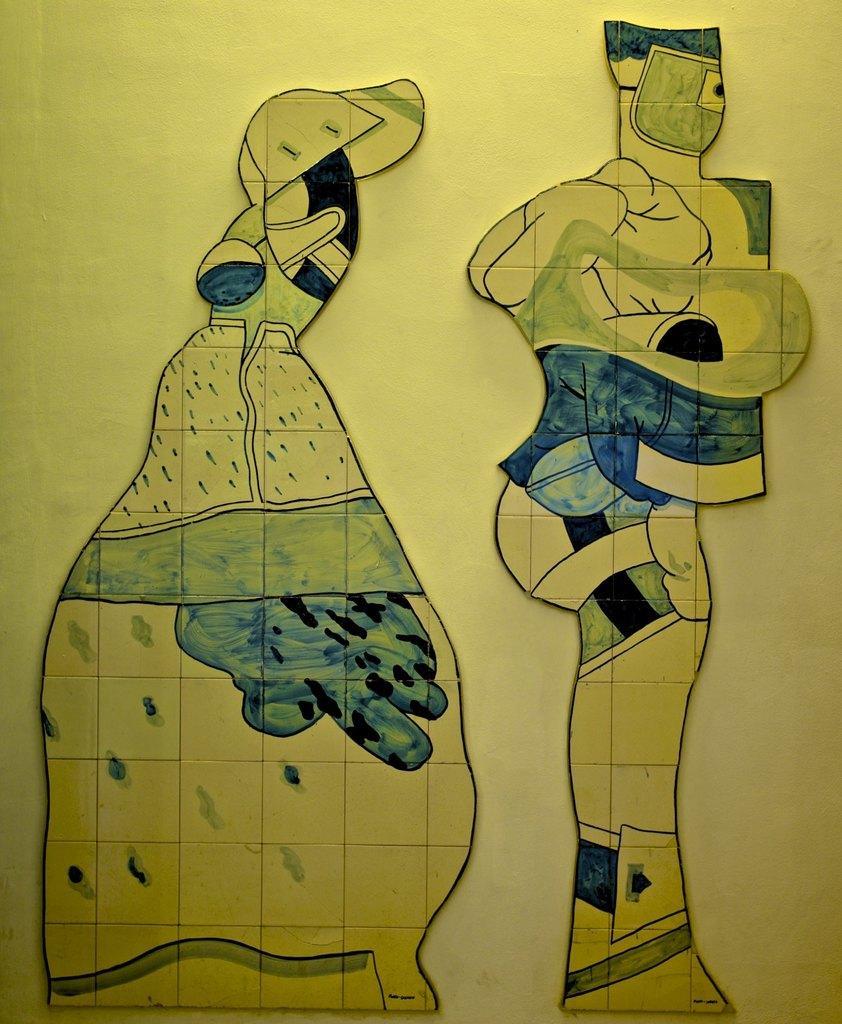In one or two sentences, can you explain what this image depicts? In this picture I can see the painting in front which is of light green blue and black color. 